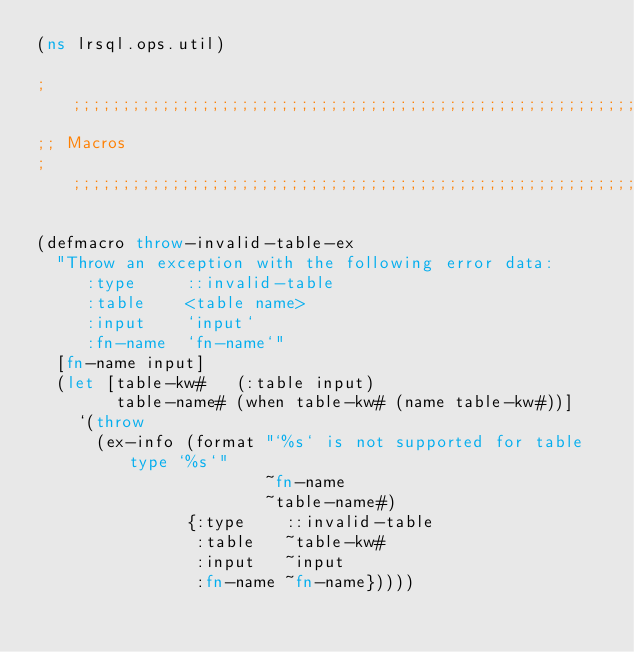Convert code to text. <code><loc_0><loc_0><loc_500><loc_500><_Clojure_>(ns lrsql.ops.util)

;;;;;;;;;;;;;;;;;;;;;;;;;;;;;;;;;;;;;;;;;;;;;;;;;;;;;;;;;;;;;;;;;;;;;;;;;;;;;;;;
;; Macros
;;;;;;;;;;;;;;;;;;;;;;;;;;;;;;;;;;;;;;;;;;;;;;;;;;;;;;;;;;;;;;;;;;;;;;;;;;;;;;;;

(defmacro throw-invalid-table-ex
  "Throw an exception with the following error data:
     :type     ::invalid-table
     :table    <table name>
     :input    `input`
     :fn-name  `fn-name`"
  [fn-name input]
  (let [table-kw#   (:table input)
        table-name# (when table-kw# (name table-kw#))]
    `(throw
      (ex-info (format "`%s` is not supported for table type `%s`"
                       ~fn-name
                       ~table-name#)
               {:type    ::invalid-table
                :table   ~table-kw#
                :input   ~input
                :fn-name ~fn-name}))))
</code> 